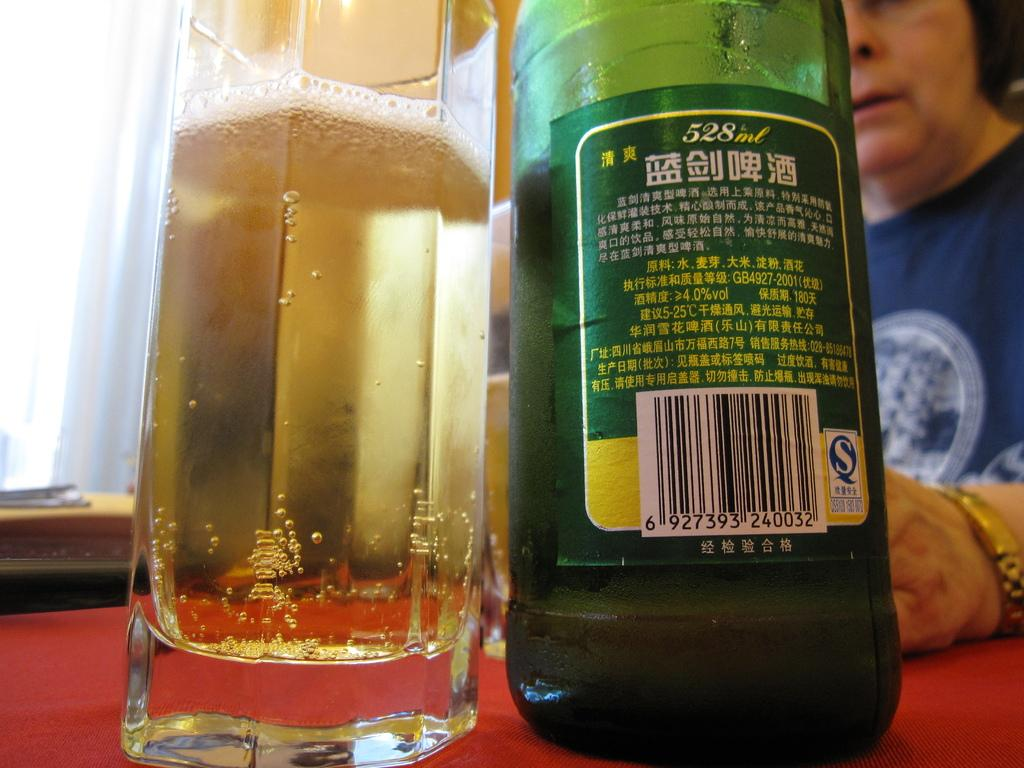What is on the table in the image? There is a glass and a wine bottle on the table. Who is present in the image? A woman is sitting in front of the glass and wine bottle. Where are the glass and wine bottle located? The glass, wine bottle, and woman are on a table. What type of wool is being used to make a wish in the image? There is no wool or wish-making activity present in the image. 